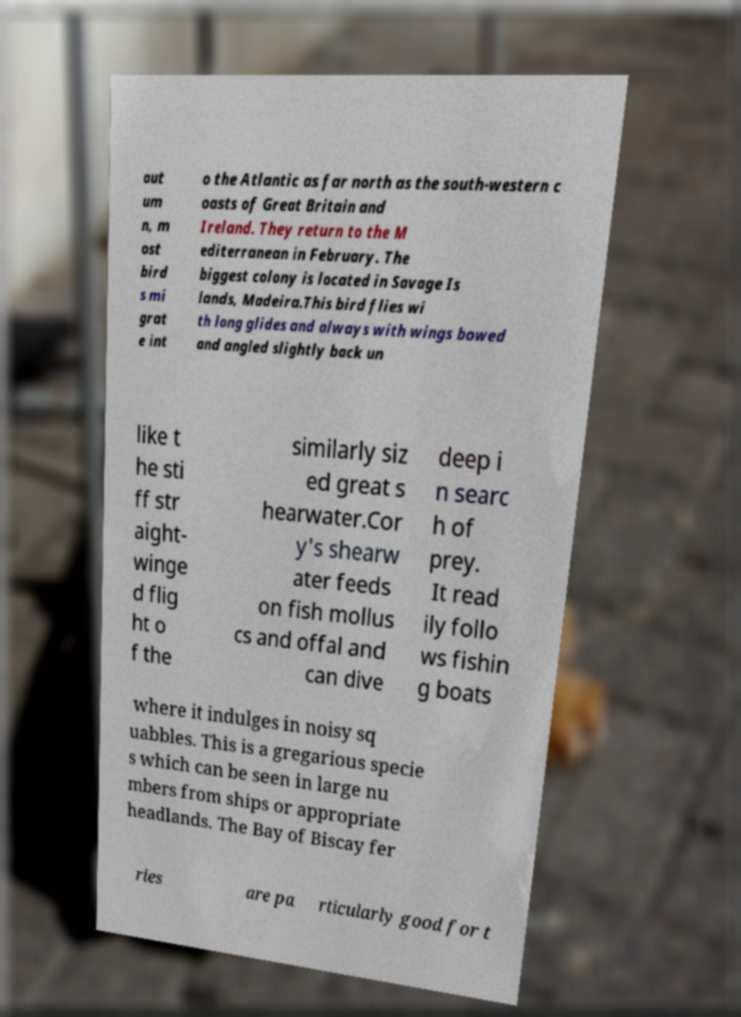Please identify and transcribe the text found in this image. aut um n, m ost bird s mi grat e int o the Atlantic as far north as the south-western c oasts of Great Britain and Ireland. They return to the M editerranean in February. The biggest colony is located in Savage Is lands, Madeira.This bird flies wi th long glides and always with wings bowed and angled slightly back un like t he sti ff str aight- winge d flig ht o f the similarly siz ed great s hearwater.Cor y's shearw ater feeds on fish mollus cs and offal and can dive deep i n searc h of prey. It read ily follo ws fishin g boats where it indulges in noisy sq uabbles. This is a gregarious specie s which can be seen in large nu mbers from ships or appropriate headlands. The Bay of Biscay fer ries are pa rticularly good for t 